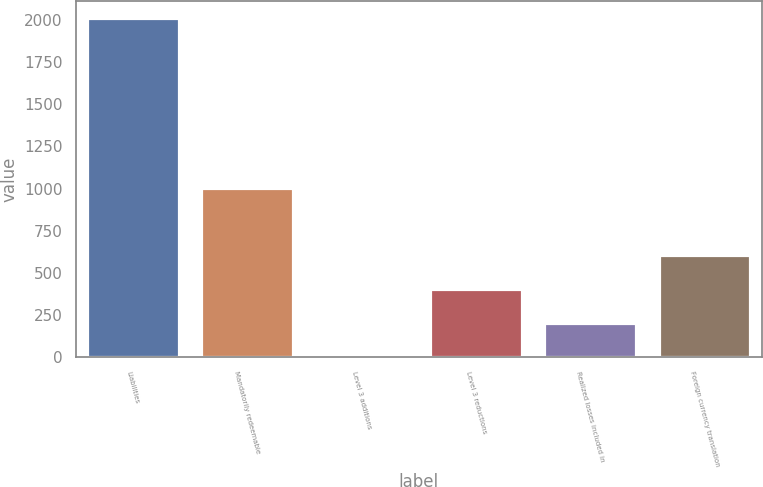Convert chart. <chart><loc_0><loc_0><loc_500><loc_500><bar_chart><fcel>Liabilities<fcel>Mandatorily redeemable<fcel>Level 3 additions<fcel>Level 3 reductions<fcel>Realized losses included in<fcel>Foreign currency translation<nl><fcel>2013<fcel>1006.6<fcel>0.2<fcel>402.76<fcel>201.48<fcel>604.04<nl></chart> 